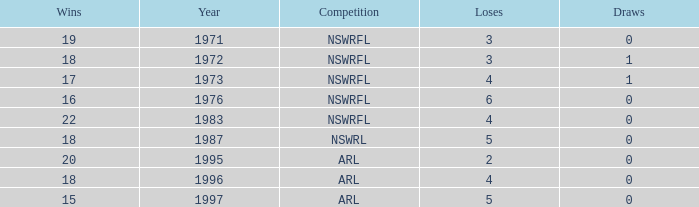What average Year has Losses 4, and Wins less than 18, and Draws greater than 1? None. 